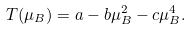<formula> <loc_0><loc_0><loc_500><loc_500>T ( \mu _ { B } ) = a - b \mu _ { B } ^ { 2 } - c \mu _ { B } ^ { 4 } .</formula> 